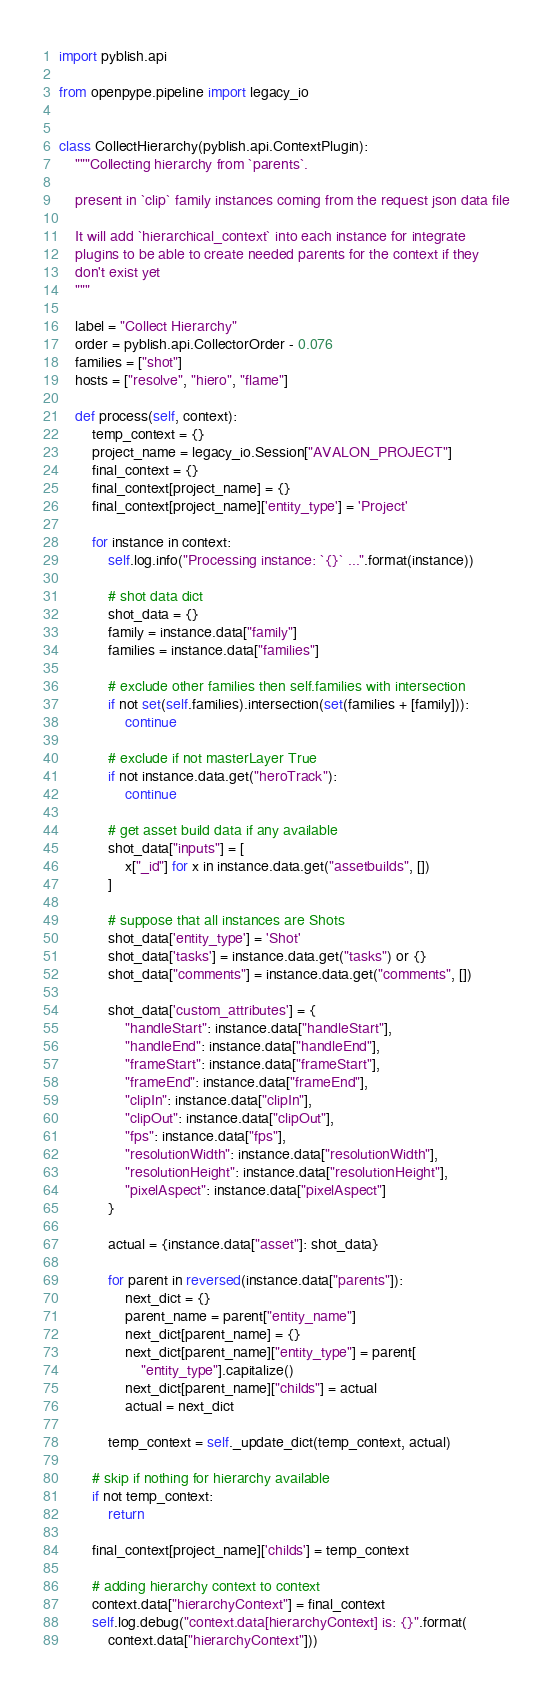<code> <loc_0><loc_0><loc_500><loc_500><_Python_>import pyblish.api

from openpype.pipeline import legacy_io


class CollectHierarchy(pyblish.api.ContextPlugin):
    """Collecting hierarchy from `parents`.

    present in `clip` family instances coming from the request json data file

    It will add `hierarchical_context` into each instance for integrate
    plugins to be able to create needed parents for the context if they
    don't exist yet
    """

    label = "Collect Hierarchy"
    order = pyblish.api.CollectorOrder - 0.076
    families = ["shot"]
    hosts = ["resolve", "hiero", "flame"]

    def process(self, context):
        temp_context = {}
        project_name = legacy_io.Session["AVALON_PROJECT"]
        final_context = {}
        final_context[project_name] = {}
        final_context[project_name]['entity_type'] = 'Project'

        for instance in context:
            self.log.info("Processing instance: `{}` ...".format(instance))

            # shot data dict
            shot_data = {}
            family = instance.data["family"]
            families = instance.data["families"]

            # exclude other families then self.families with intersection
            if not set(self.families).intersection(set(families + [family])):
                continue

            # exclude if not masterLayer True
            if not instance.data.get("heroTrack"):
                continue

            # get asset build data if any available
            shot_data["inputs"] = [
                x["_id"] for x in instance.data.get("assetbuilds", [])
            ]

            # suppose that all instances are Shots
            shot_data['entity_type'] = 'Shot'
            shot_data['tasks'] = instance.data.get("tasks") or {}
            shot_data["comments"] = instance.data.get("comments", [])

            shot_data['custom_attributes'] = {
                "handleStart": instance.data["handleStart"],
                "handleEnd": instance.data["handleEnd"],
                "frameStart": instance.data["frameStart"],
                "frameEnd": instance.data["frameEnd"],
                "clipIn": instance.data["clipIn"],
                "clipOut": instance.data["clipOut"],
                "fps": instance.data["fps"],
                "resolutionWidth": instance.data["resolutionWidth"],
                "resolutionHeight": instance.data["resolutionHeight"],
                "pixelAspect": instance.data["pixelAspect"]
            }

            actual = {instance.data["asset"]: shot_data}

            for parent in reversed(instance.data["parents"]):
                next_dict = {}
                parent_name = parent["entity_name"]
                next_dict[parent_name] = {}
                next_dict[parent_name]["entity_type"] = parent[
                    "entity_type"].capitalize()
                next_dict[parent_name]["childs"] = actual
                actual = next_dict

            temp_context = self._update_dict(temp_context, actual)

        # skip if nothing for hierarchy available
        if not temp_context:
            return

        final_context[project_name]['childs'] = temp_context

        # adding hierarchy context to context
        context.data["hierarchyContext"] = final_context
        self.log.debug("context.data[hierarchyContext] is: {}".format(
            context.data["hierarchyContext"]))
</code> 